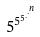<formula> <loc_0><loc_0><loc_500><loc_500>5 ^ { 5 ^ { 5 ^ { . ^ { . ^ { n } } } } }</formula> 